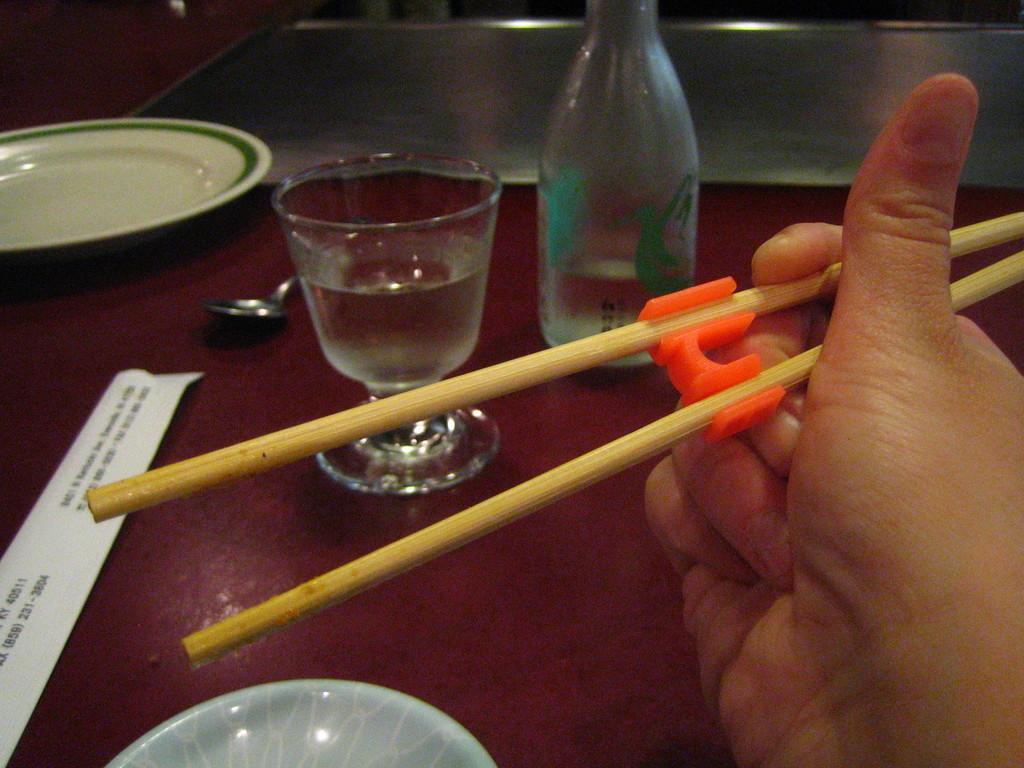Can you describe this image briefly? In the middle of the image there is a table. On the table there is a glass. Top right side there is a bottle. Top left side there is a plate. In the middle of the table there is a spoon. Right side of the image some person holding the chopsticks. 